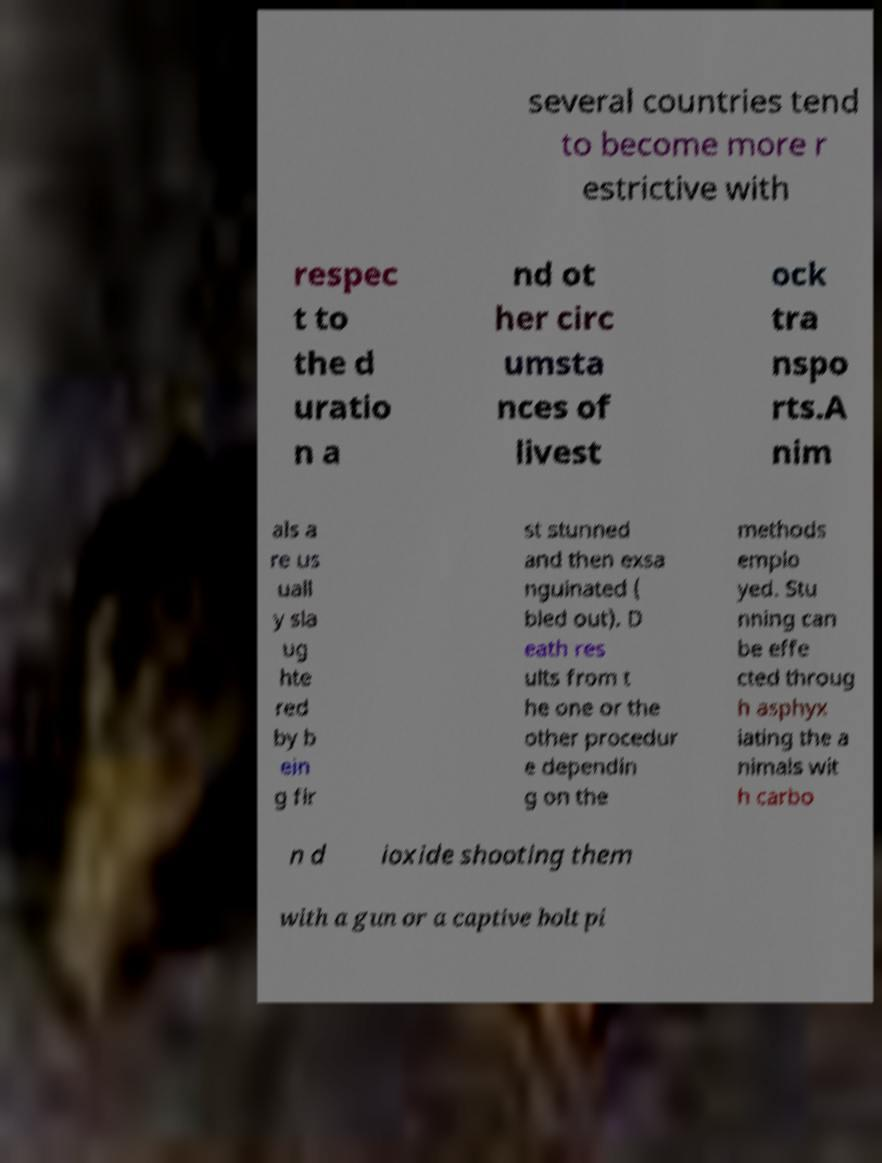I need the written content from this picture converted into text. Can you do that? several countries tend to become more r estrictive with respec t to the d uratio n a nd ot her circ umsta nces of livest ock tra nspo rts.A nim als a re us uall y sla ug hte red by b ein g fir st stunned and then exsa nguinated ( bled out). D eath res ults from t he one or the other procedur e dependin g on the methods emplo yed. Stu nning can be effe cted throug h asphyx iating the a nimals wit h carbo n d ioxide shooting them with a gun or a captive bolt pi 